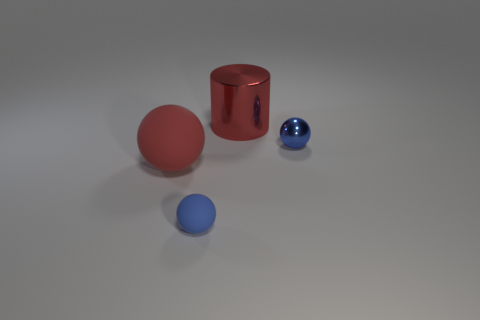Can you tell me what objects are in the image? The image depicts three objects: a red cylinder with a reflective surface, a large matte red sphere, and a small shiny blue sphere. 